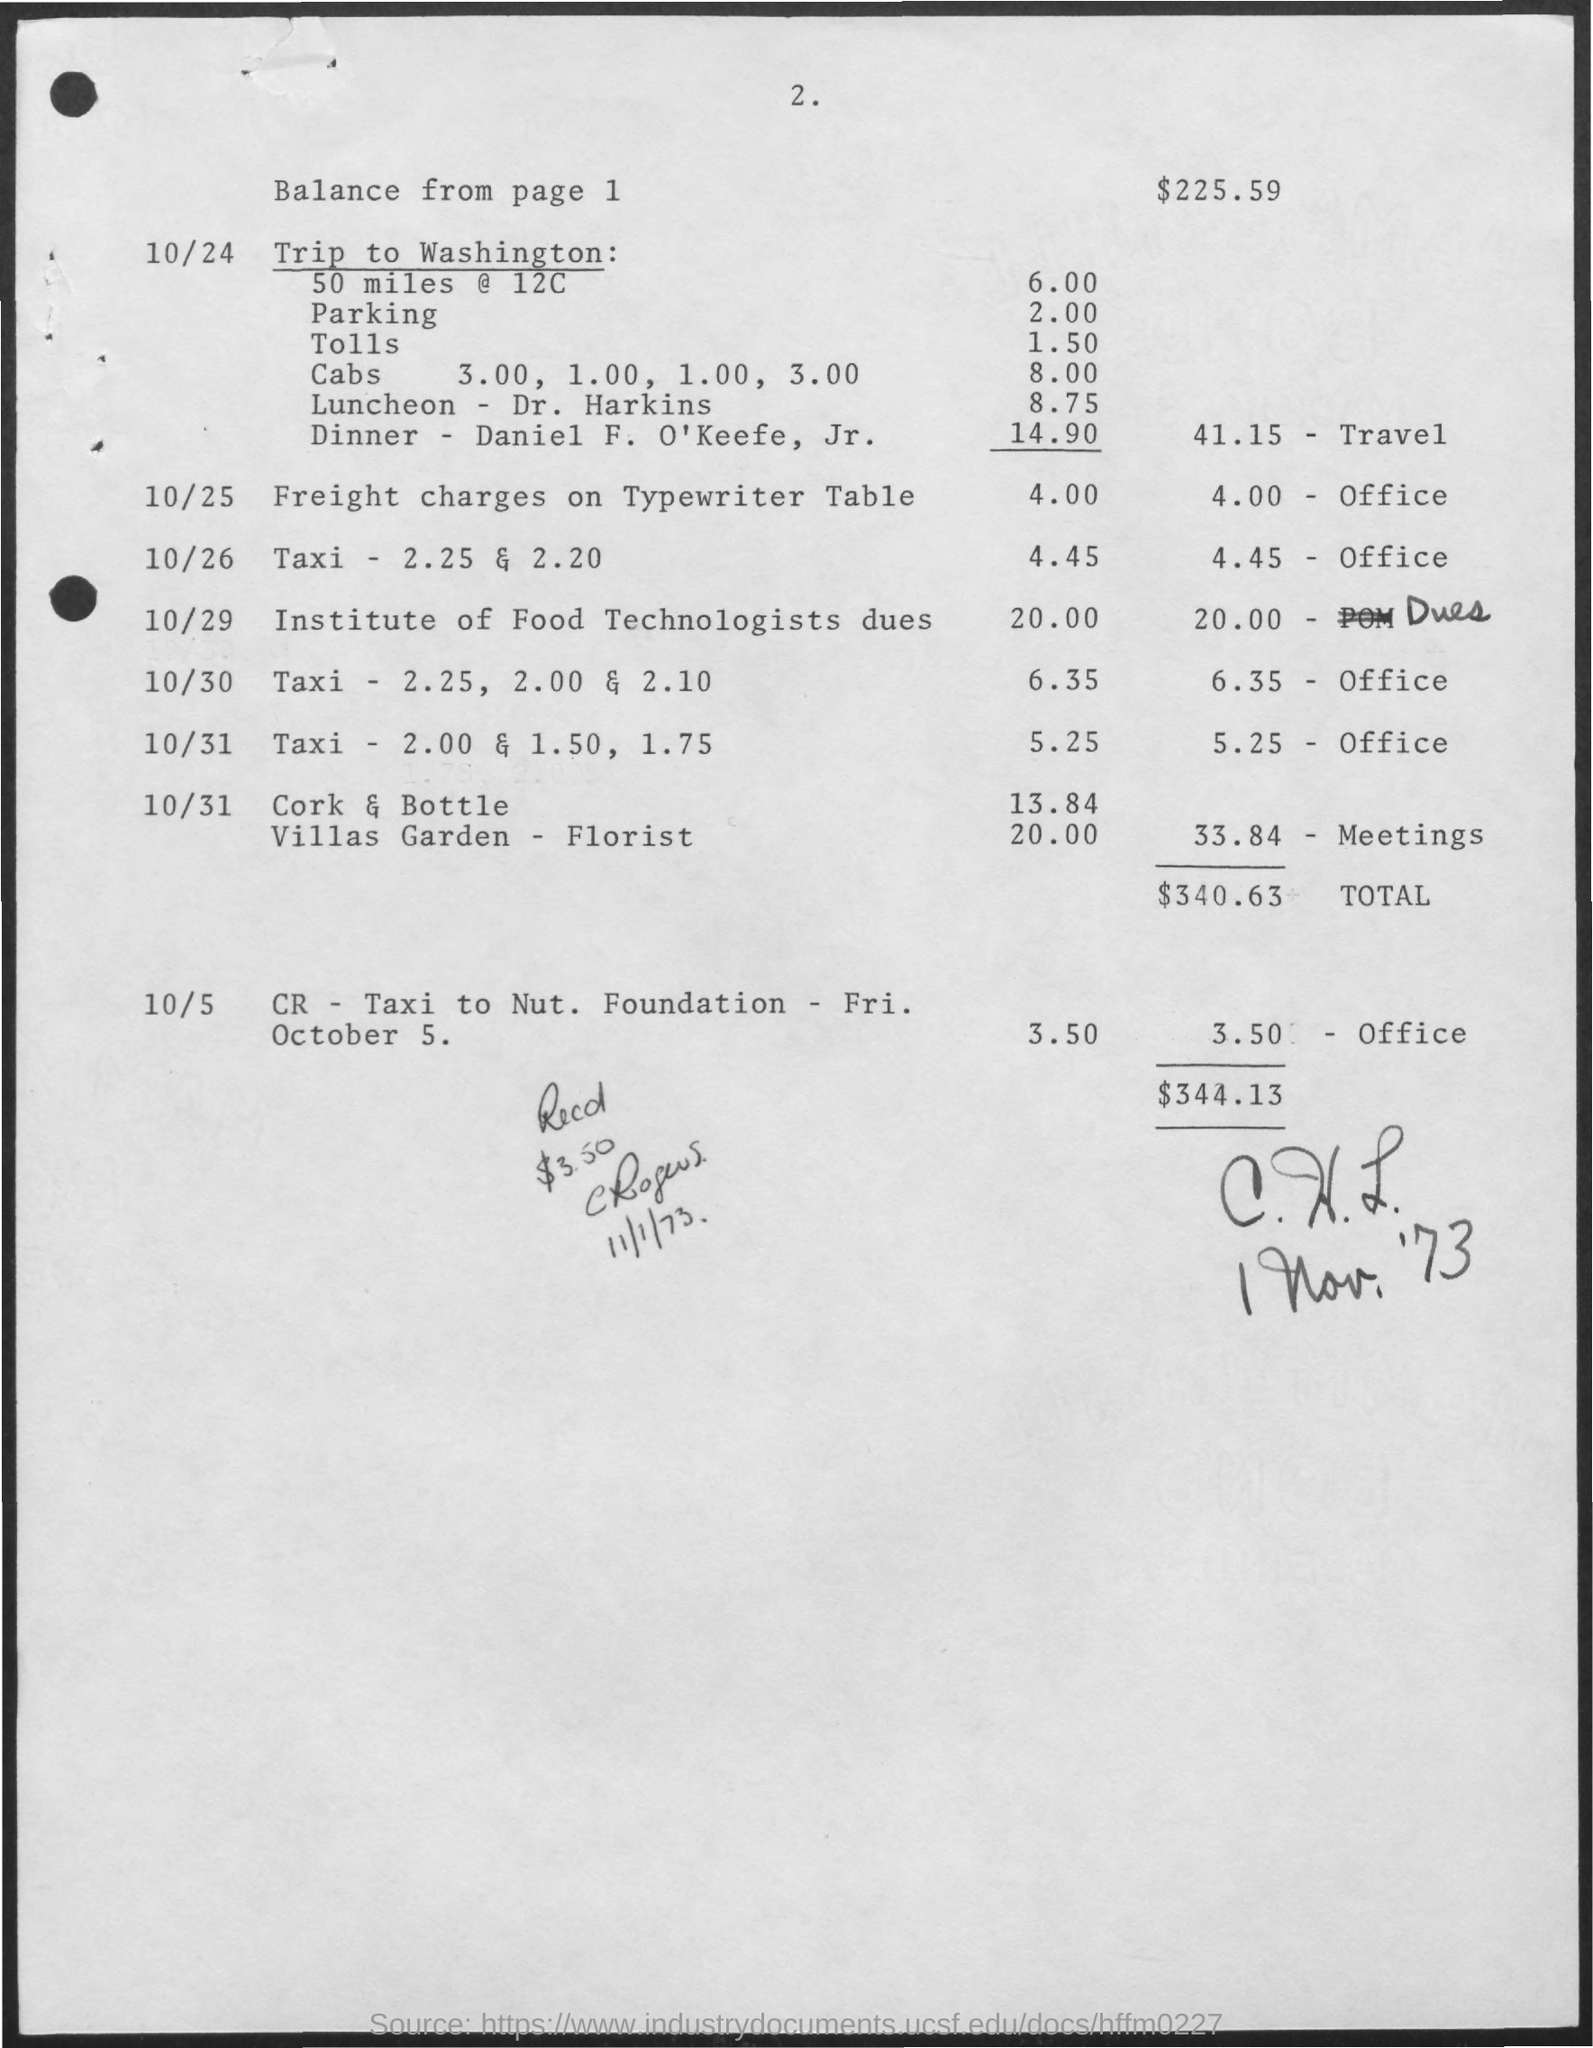Highlight a few significant elements in this photo. The amount for dinner is $14.90, as listed by Daniel F. O'Keefe, Jr. The toll for one trip is 1.50. The cost of lunch with Dr. Harkins is $8.75. I inquire about the cost of taxi service, and I am charged $8.00. 